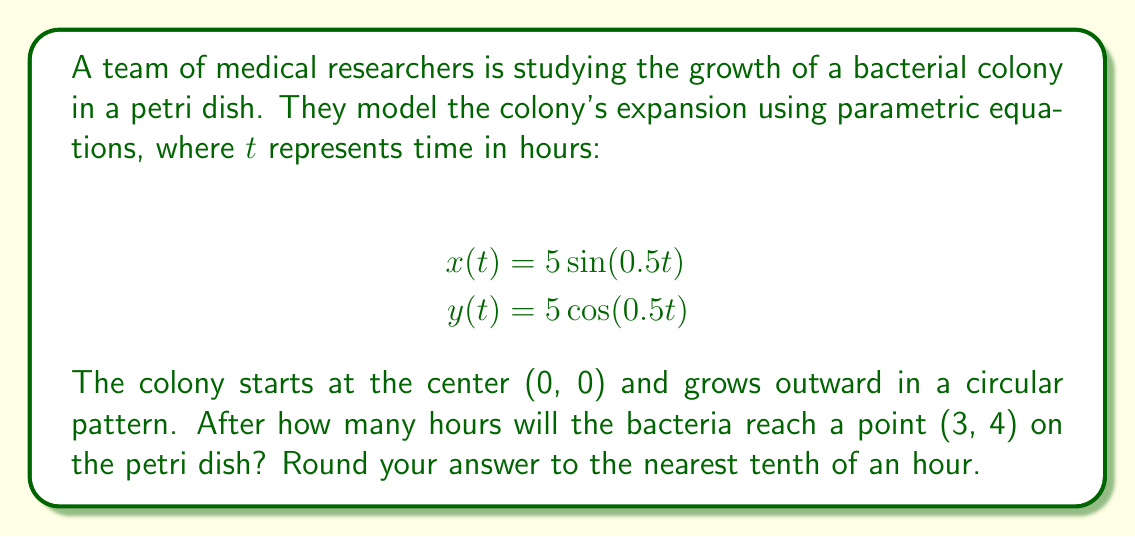Can you answer this question? Let's approach this step-by-step:

1) First, we need to recognize that the given parametric equations describe a circle with radius 5 units. The bacteria are moving along this circle as time progresses.

2) To find when the bacteria reach the point (3, 4), we need to solve the system of equations:

   $$3 = 5\sin(0.5t)$$
   $$4 = 5\cos(0.5t)$$

3) We can use the Pythagorean identity $\sin^2(θ) + \cos^2(θ) = 1$ to verify:

   $$(\frac{3}{5})^2 + (\frac{4}{5})^2 = \frac{9}{25} + \frac{16}{25} = 1$$

   This confirms that (3, 4) is indeed on the circle.

4) To find $t$, we can use the arctangent function:

   $$t = \frac{2}{\pi} \arctan(\frac{y}{x}) = \frac{2}{\pi} \arctan(\frac{4}{3})$$

5) Calculate:
   $$t = \frac{2}{\pi} \arctan(\frac{4}{3}) \approx 0.7297$$

6) However, this gives us the angle in radians. We need to convert this to time.

   From the original equations, we see that when $t = 2\pi$, the angle completes one full rotation.

   So, we can set up the proportion:
   $$\frac{0.7297}{t} = \frac{2\pi}{2\pi}$$

7) Solve for $t$:
   $$t = \frac{0.7297 * 2\pi}{2\pi} = 0.7297 * 2\pi \approx 4.5837$$

8) Rounding to the nearest tenth:
   $$t \approx 4.6$$
Answer: The bacteria will reach the point (3, 4) after approximately 4.6 hours. 